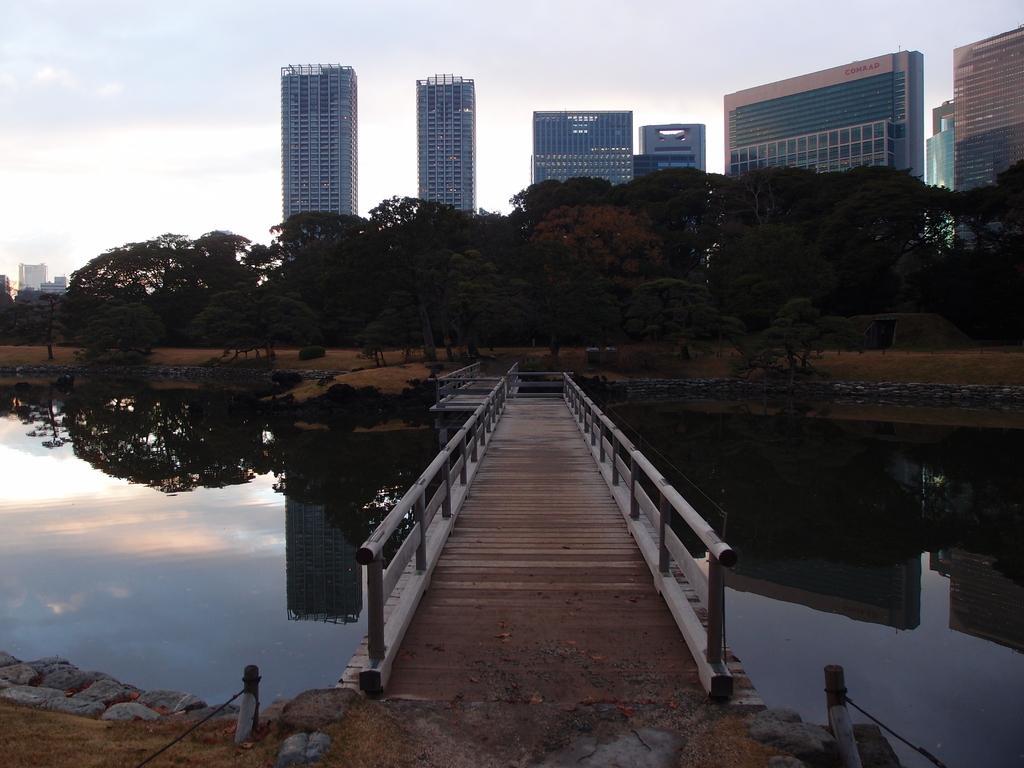Could you give a brief overview of what you see in this image? In this image we can see the wooden bridge, small poles with ropes. We can also see the stones. In the background there are buildings and also trees. We can also see the sky. 